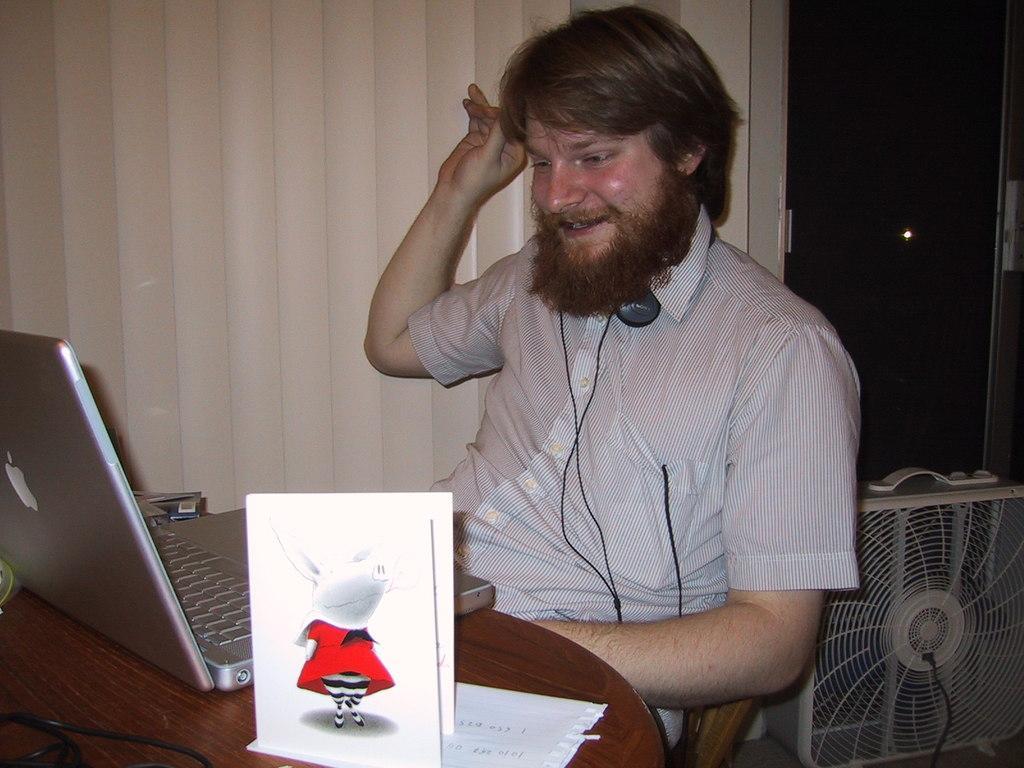Describe this image in one or two sentences. In this picture there is a guy sitting on a round table and a laptop in front of him. There is also a label on which cartoon design is printed. In the background we observe a table fan. 